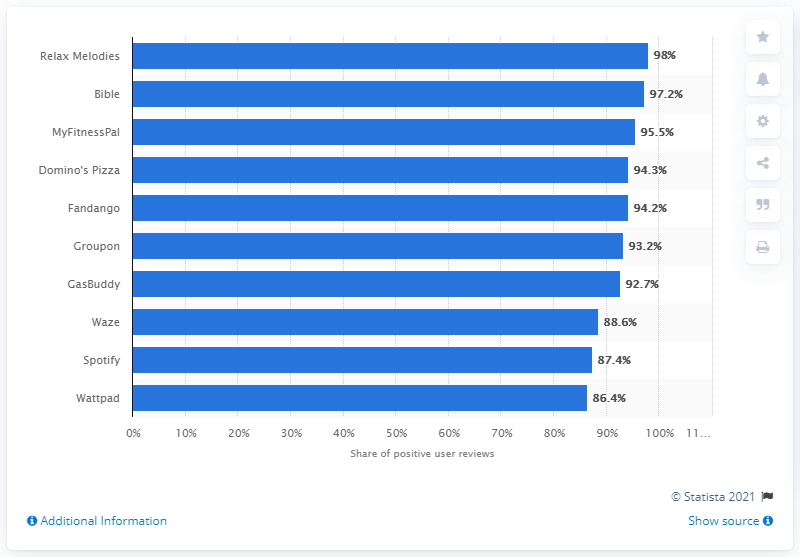Point out several critical features in this image. The name of the sleep and meditation sounds generator is Relax Melodies. 